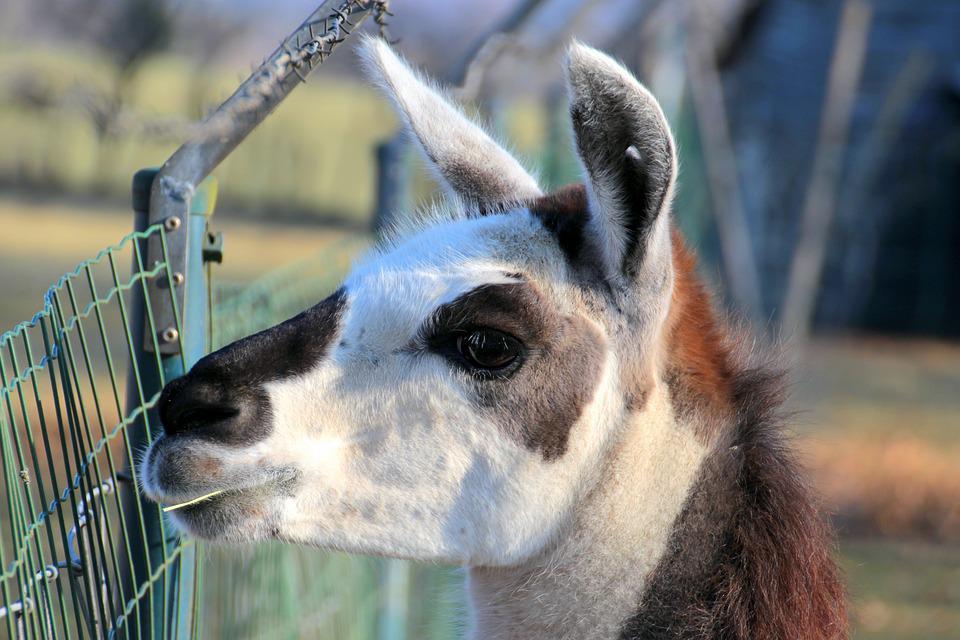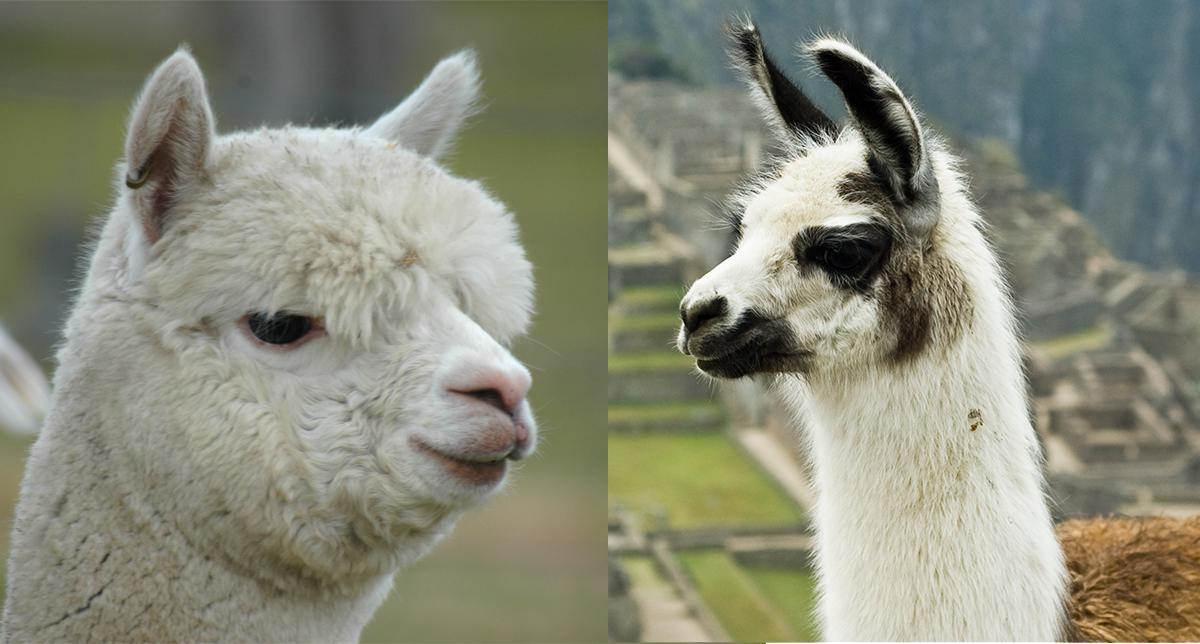The first image is the image on the left, the second image is the image on the right. Considering the images on both sides, is "There are exactly two llamas." valid? Answer yes or no. No. 